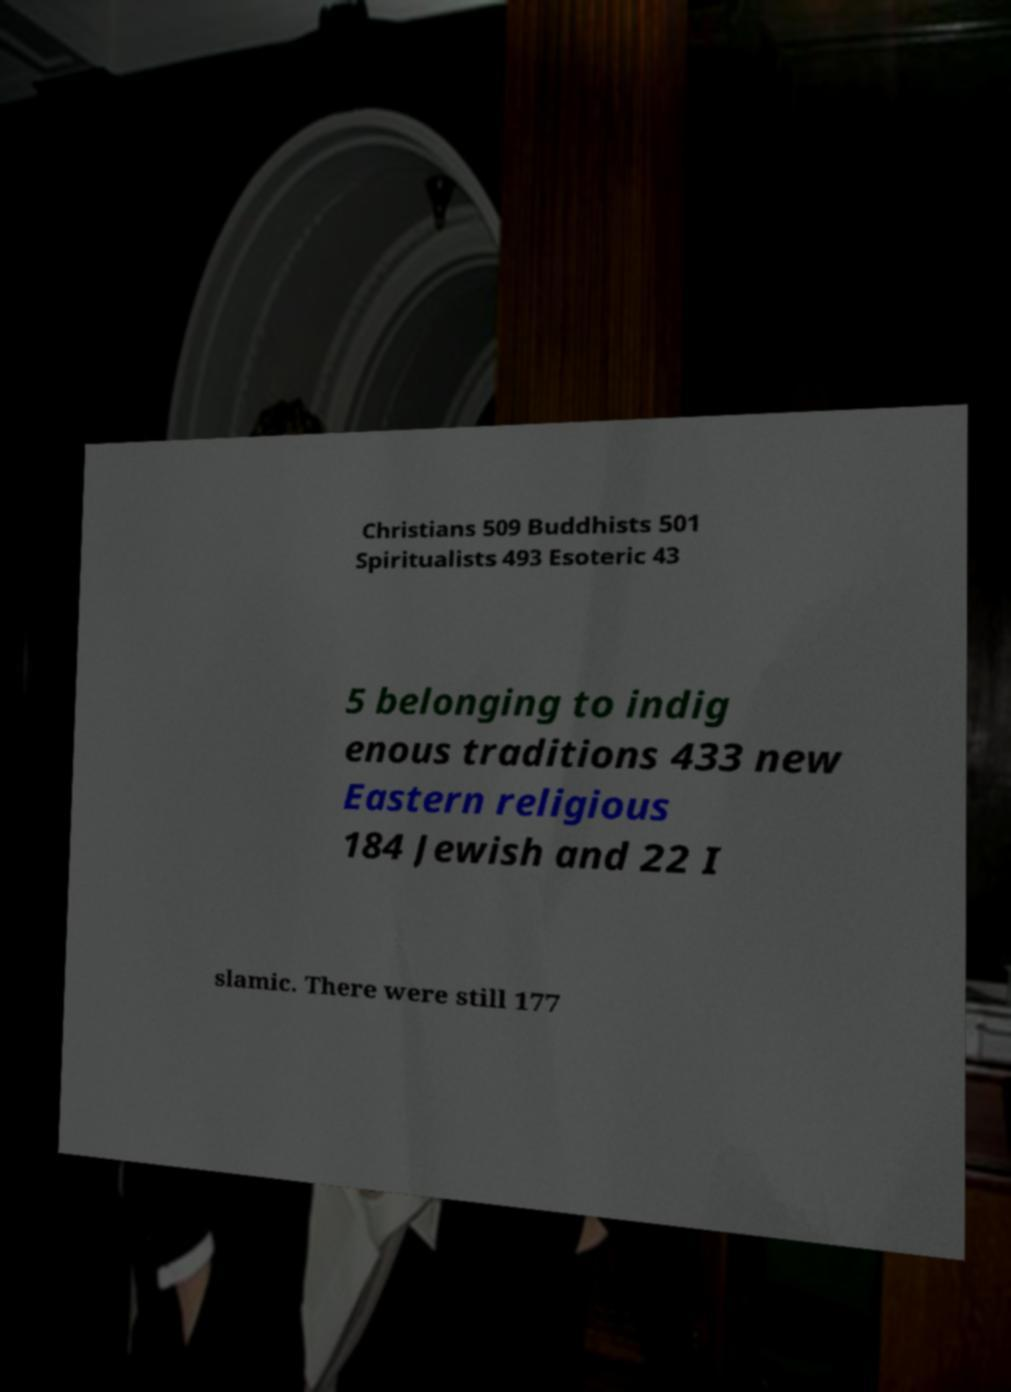What messages or text are displayed in this image? I need them in a readable, typed format. Christians 509 Buddhists 501 Spiritualists 493 Esoteric 43 5 belonging to indig enous traditions 433 new Eastern religious 184 Jewish and 22 I slamic. There were still 177 